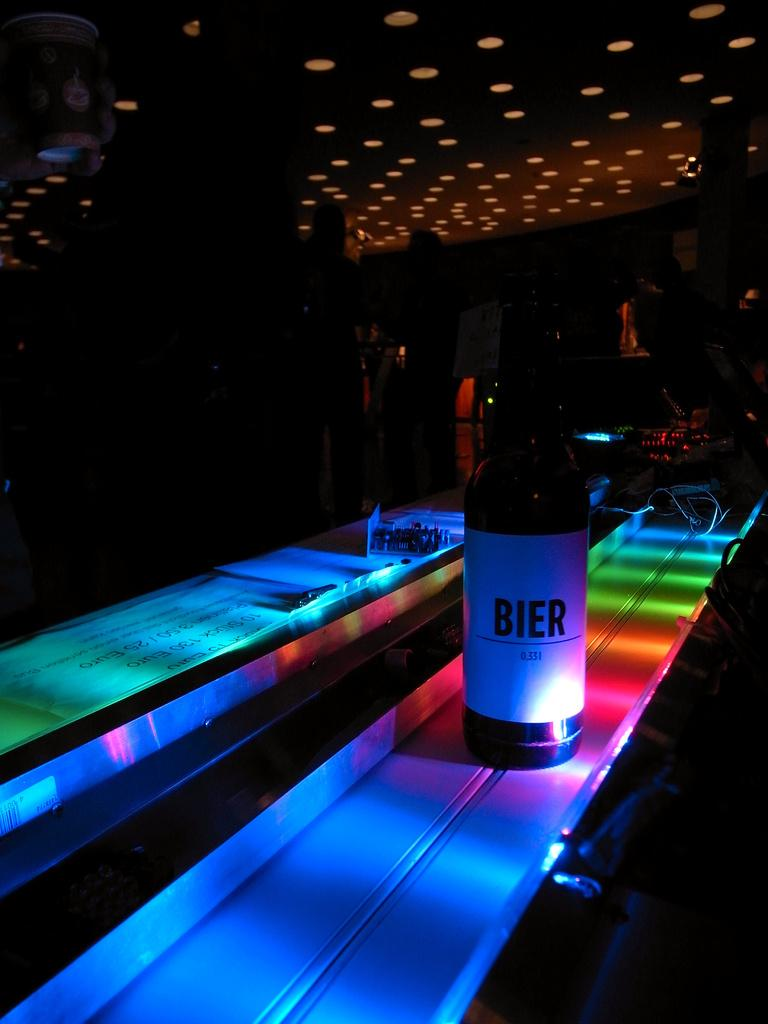Provide a one-sentence caption for the provided image. A colorful lighted bar has a bottle of BIER on it. 